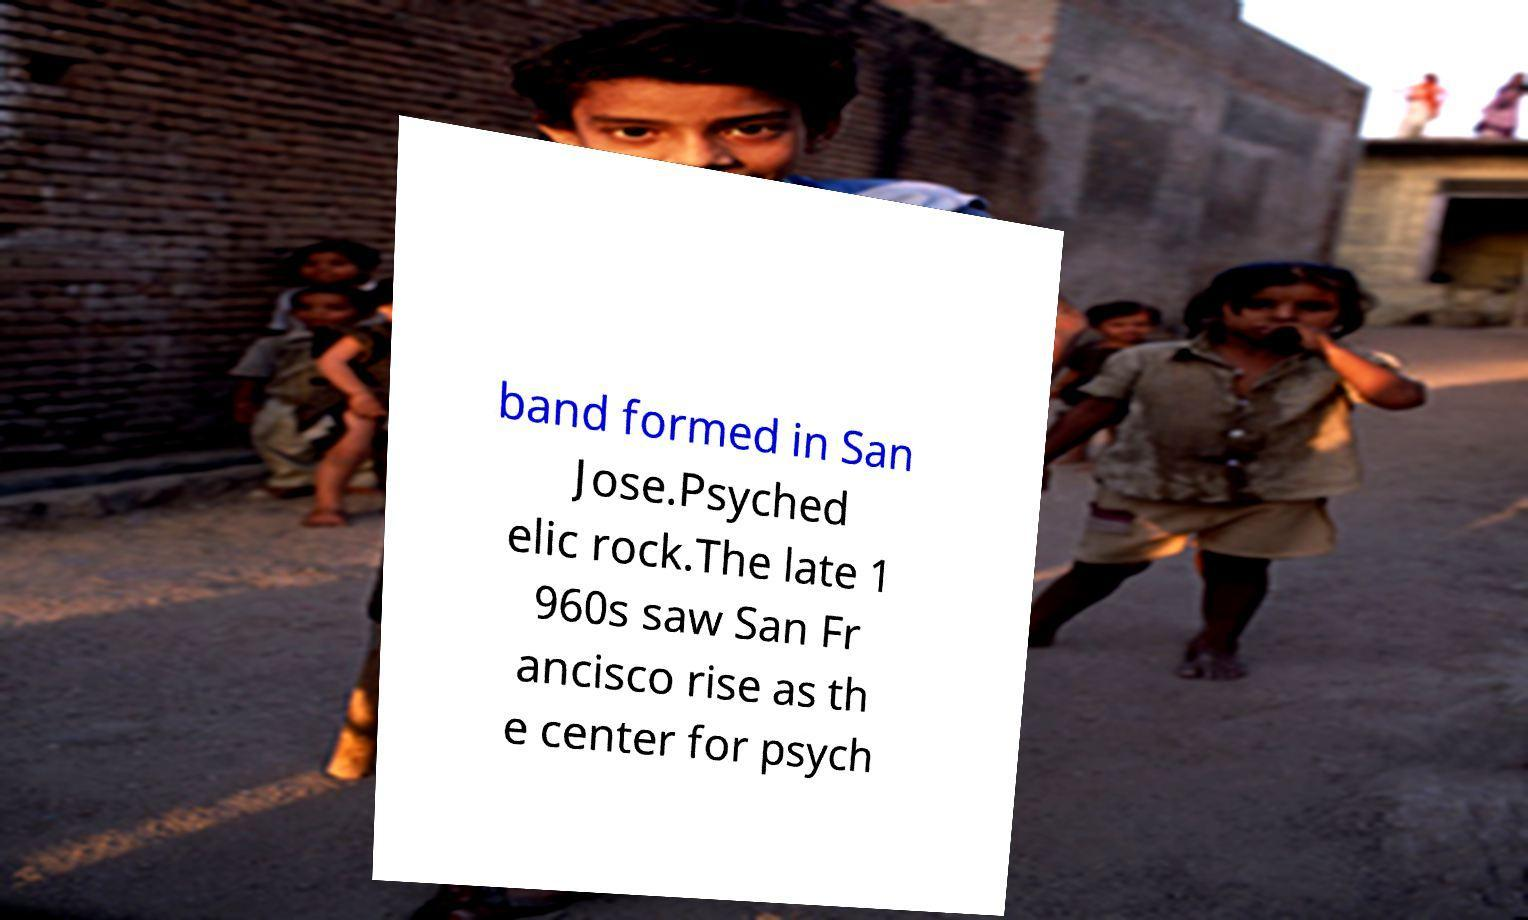Can you read and provide the text displayed in the image?This photo seems to have some interesting text. Can you extract and type it out for me? band formed in San Jose.Psyched elic rock.The late 1 960s saw San Fr ancisco rise as th e center for psych 